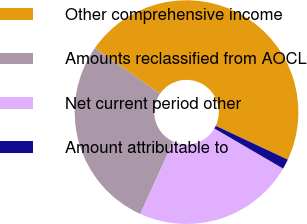<chart> <loc_0><loc_0><loc_500><loc_500><pie_chart><fcel>Other comprehensive income<fcel>Amounts reclassified from AOCL<fcel>Net current period other<fcel>Amount attributable to<nl><fcel>47.27%<fcel>27.93%<fcel>23.35%<fcel>1.44%<nl></chart> 